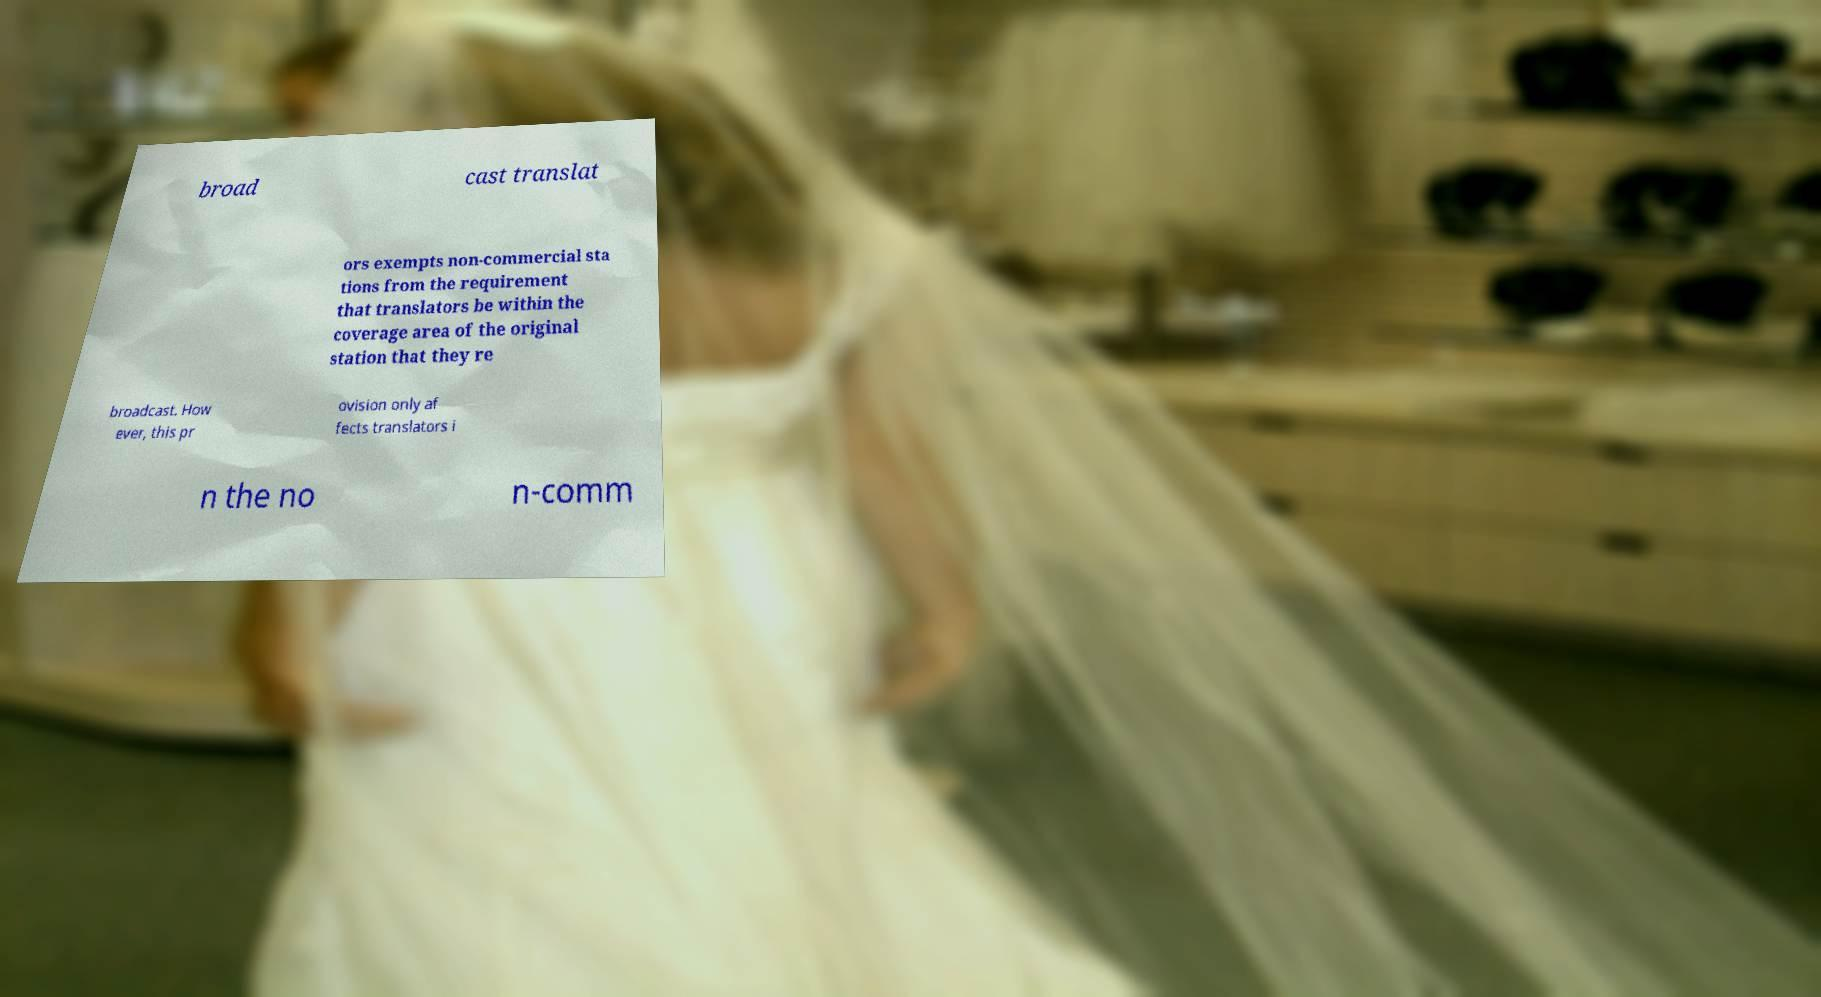Could you assist in decoding the text presented in this image and type it out clearly? broad cast translat ors exempts non-commercial sta tions from the requirement that translators be within the coverage area of the original station that they re broadcast. How ever, this pr ovision only af fects translators i n the no n-comm 